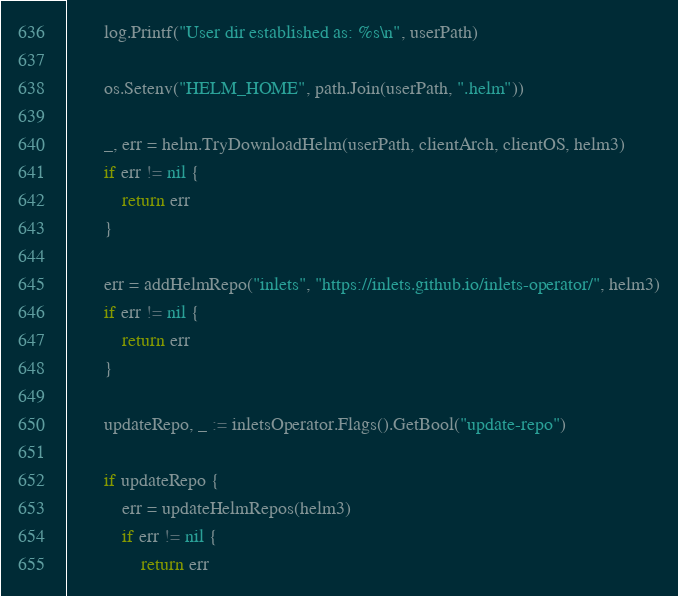Convert code to text. <code><loc_0><loc_0><loc_500><loc_500><_Go_>		log.Printf("User dir established as: %s\n", userPath)

		os.Setenv("HELM_HOME", path.Join(userPath, ".helm"))

		_, err = helm.TryDownloadHelm(userPath, clientArch, clientOS, helm3)
		if err != nil {
			return err
		}

		err = addHelmRepo("inlets", "https://inlets.github.io/inlets-operator/", helm3)
		if err != nil {
			return err
		}

		updateRepo, _ := inletsOperator.Flags().GetBool("update-repo")

		if updateRepo {
			err = updateHelmRepos(helm3)
			if err != nil {
				return err</code> 